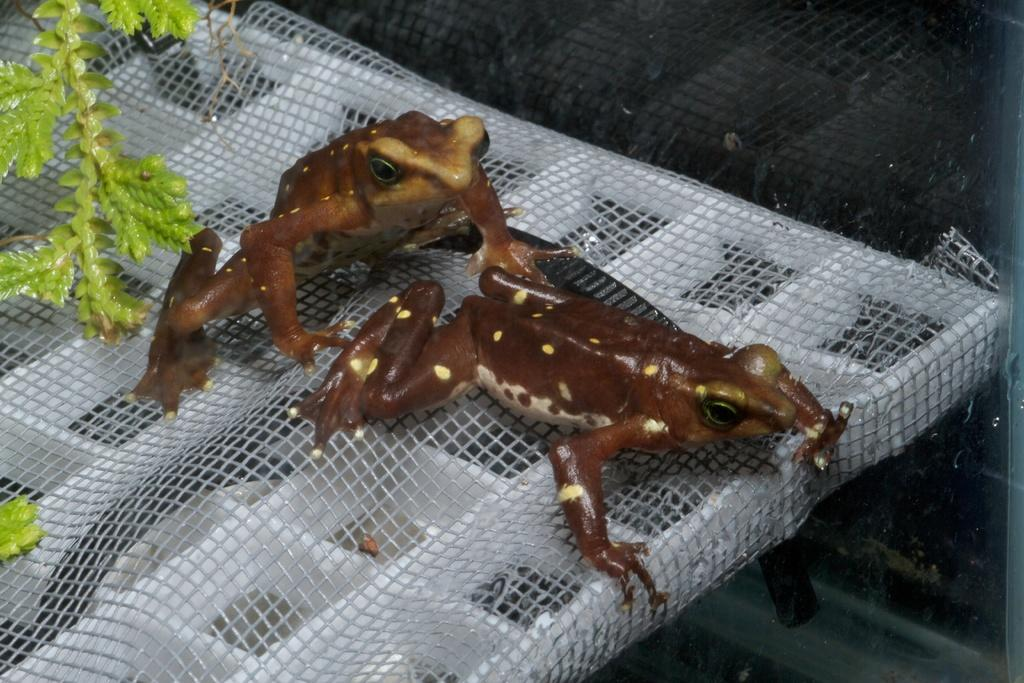How many frogs are present in the image? There are two frogs in the image. What are the frogs sitting on in the image? The frogs are on a white object. What type of vegetation can be seen in the image? There are green color leaves in the image. Where is the sink located in the image? There is no sink present in the image. Can you tell me how many cows are visible in the image? There are no cows visible in the image. 